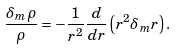Convert formula to latex. <formula><loc_0><loc_0><loc_500><loc_500>\frac { \delta _ { m } \rho } { \rho } = - \frac { 1 } { r ^ { 2 } } \frac { d } { d r } \left ( r ^ { 2 } \delta _ { m } r \right ) .</formula> 